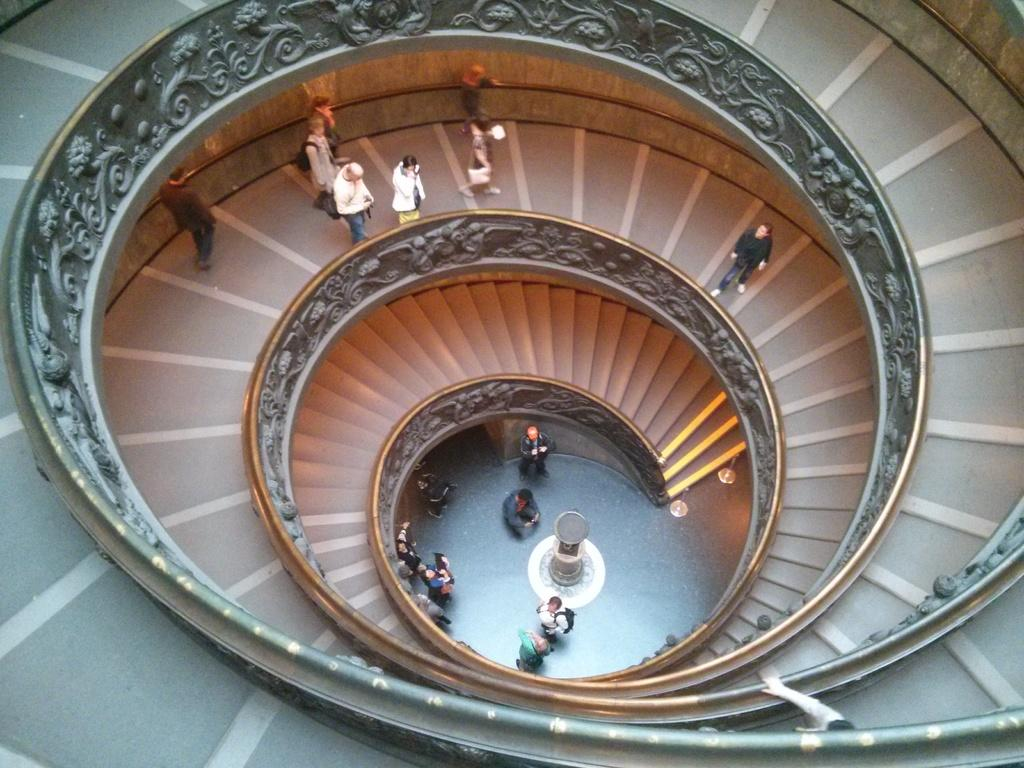What type of steps are depicted in the image? There are spiral steps in the image. How many people can be seen on the steps? There are many people on the steps. What is located next to the steps? There is a small wall on the side of the steps. What can be found on the small wall? The small wall has some art on it. What type of steel rail can be seen surrounding the steps in the image? There is no steel rail surrounding the steps in the image; it only shows spiral steps, people, and a small wall with art. 